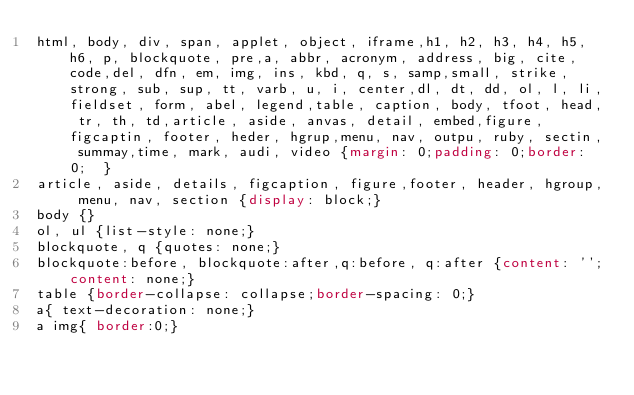<code> <loc_0><loc_0><loc_500><loc_500><_CSS_>html, body, div, span, applet, object, iframe,h1, h2, h3, h4, h5, h6, p, blockquote, pre,a, abbr, acronym, address, big, cite, code,del, dfn, em, img, ins, kbd, q, s, samp,small, strike, strong, sub, sup, tt, varb, u, i, center,dl, dt, dd, ol, l, li,fieldset, form, abel, legend,table, caption, body, tfoot, head, tr, th, td,article, aside, anvas, detail, embed,figure, figcaptin, footer, heder, hgrup,menu, nav, outpu, ruby, sectin, summay,time, mark, audi, video {margin: 0;padding: 0;border: 0;  }
article, aside, details, figcaption, figure,footer, header, hgroup, menu, nav, section {display: block;}
body {}
ol, ul {list-style: none;}
blockquote, q {quotes: none;}
blockquote:before, blockquote:after,q:before, q:after {content: '';content: none;}
table {border-collapse: collapse;border-spacing: 0;}
a{ text-decoration: none;}
a img{ border:0;}</code> 